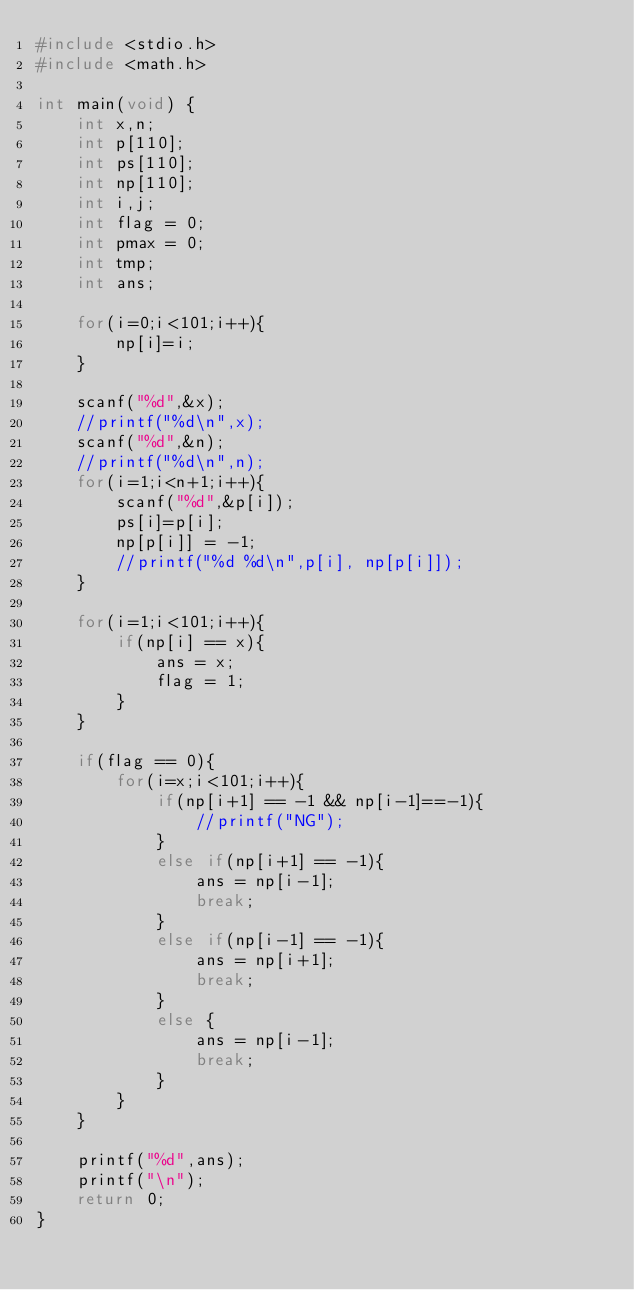Convert code to text. <code><loc_0><loc_0><loc_500><loc_500><_C_>#include <stdio.h>
#include <math.h>

int main(void) {
	int x,n;
	int p[110];
	int ps[110];
	int np[110];
	int i,j;
	int flag = 0;
	int pmax = 0;
	int tmp;
	int ans;
	
	for(i=0;i<101;i++){
		np[i]=i;
	}
	
	scanf("%d",&x);
	//printf("%d\n",x);
	scanf("%d",&n);
	//printf("%d\n",n);
	for(i=1;i<n+1;i++){
		scanf("%d",&p[i]);
		ps[i]=p[i];
		np[p[i]] = -1;
		//printf("%d %d\n",p[i], np[p[i]]);
	}
	
	for(i=1;i<101;i++){
		if(np[i] == x){
			ans = x;
			flag = 1;
		}
	}
	
	if(flag == 0){
		for(i=x;i<101;i++){
			if(np[i+1] == -1 && np[i-1]==-1){
				//printf("NG");
			}
			else if(np[i+1] == -1){
				ans = np[i-1];
				break;
			}
			else if(np[i-1] == -1){
				ans = np[i+1];
				break;
			}
			else {
				ans = np[i-1];
				break;
			}
		}
	}
	
	printf("%d",ans);
	printf("\n");	
	return 0;
}
</code> 